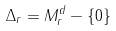Convert formula to latex. <formula><loc_0><loc_0><loc_500><loc_500>\Delta _ { r } = M _ { r } ^ { d } - \left \{ 0 \right \}</formula> 